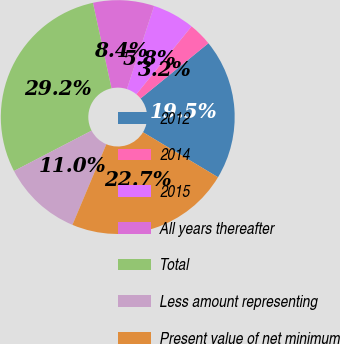Convert chart. <chart><loc_0><loc_0><loc_500><loc_500><pie_chart><fcel>2012<fcel>2014<fcel>2015<fcel>All years thereafter<fcel>Total<fcel>Less amount representing<fcel>Present value of net minimum<nl><fcel>19.48%<fcel>3.25%<fcel>5.84%<fcel>8.44%<fcel>29.22%<fcel>11.04%<fcel>22.73%<nl></chart> 